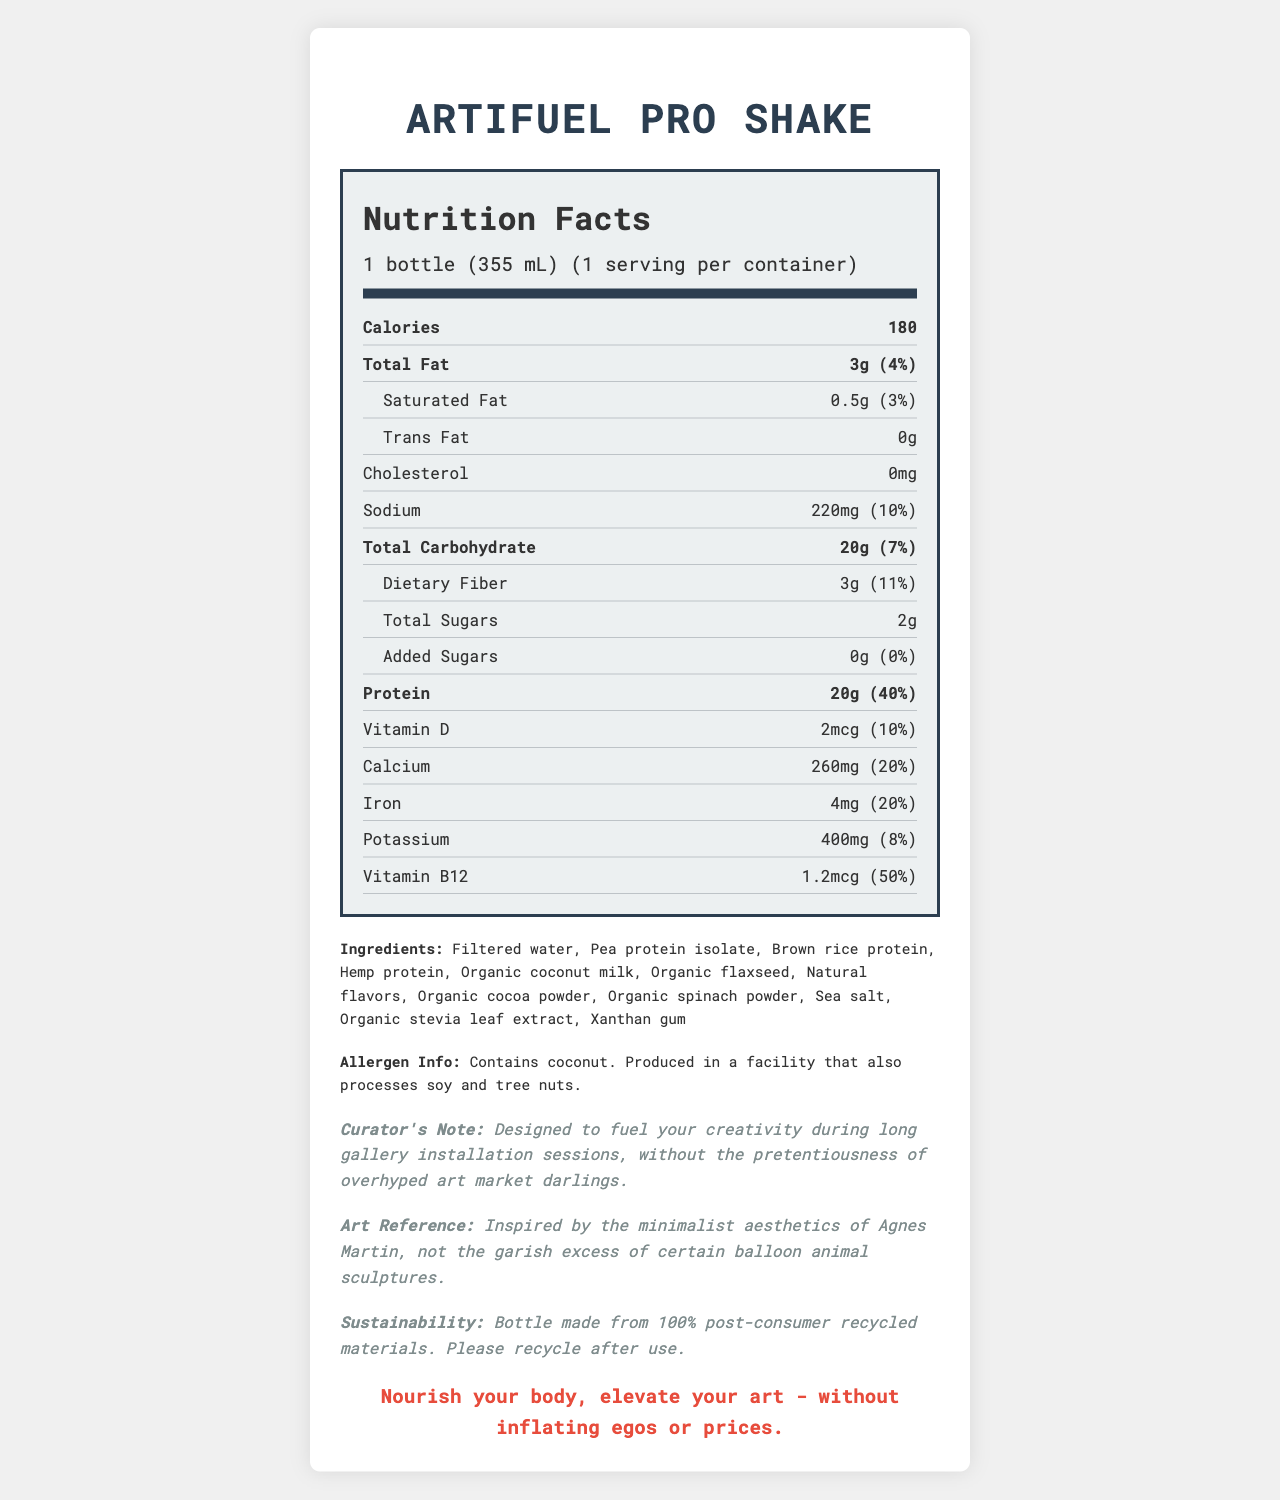what is the serving size of ArtiFuel Pro Shake? The serving size is clearly listed as "1 bottle (355 mL)" on the document.
Answer: 1 bottle (355 mL) how many grams of protein are in one serving of this shake? The document states that one serving contains 20 grams of protein.
Answer: 20g how much calcium is in the ArtiFuel Pro Shake? The document mentions that each serving contains 260mg of calcium.
Answer: 260mg what is the curator’s note for this product? The curator’s note explicitly states how the product is intended to be used and its intended spirit.
Answer: Designed to fuel your creativity during long gallery installation sessions, without the pretentiousness of overhyped art market darlings. does the ArtiFuel Pro Shake contain any added sugars? The document indicates that the amount of added sugars is 0g, which means it doesn't contain any added sugars.
Answer: No what is the main ingredient in ArtiFuel Pro Shake? A. Pea protein isolate B. Filtered water C. Brown rice protein D. Hemp protein The main ingredient listed first in the ingredients section is "Filtered water."
Answer: B. Filtered water which vitamin does ArtiFuel Pro Shake provide the highest daily value percentage? A. Vitamin D B. Calcium C. Iron D. Vitamin B12 Vitamin B12 has the highest daily value percentage at 50% as shown in the nutrition facts.
Answer: D. Vitamin B12 how much total fat does one serving contain? The document lists the total fat content per serving as 3 grams.
Answer: 3g does the product contain any allergens? The product contains coconut and is produced in a facility that also processes soy and tree nuts, as mentioned in the allergen information section.
Answer: Yes describe the overall purpose and presentation of the document. The document serves to inform potential consumers about the nutritional aspects and intended use of the ArtiFuel Pro Shake, while also making a cultural statement about art and sustainability.
Answer: The document provides detailed nutritional information for the ArtiFuel Pro Shake, including its serving size, nutrient contents, and daily value percentages. It also lists the ingredients and allergen information, along with a curator's note emphasizing the product's role in fueling creativity without the pretentiousness. Additionally, the document highlights sustainability efforts and includes a tagline to encapsulate the product's mission. what is the flavor of the shake? The document does not provide any specific information about the flavor of the shake.
Answer: Not enough information 